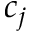Convert formula to latex. <formula><loc_0><loc_0><loc_500><loc_500>c _ { j }</formula> 